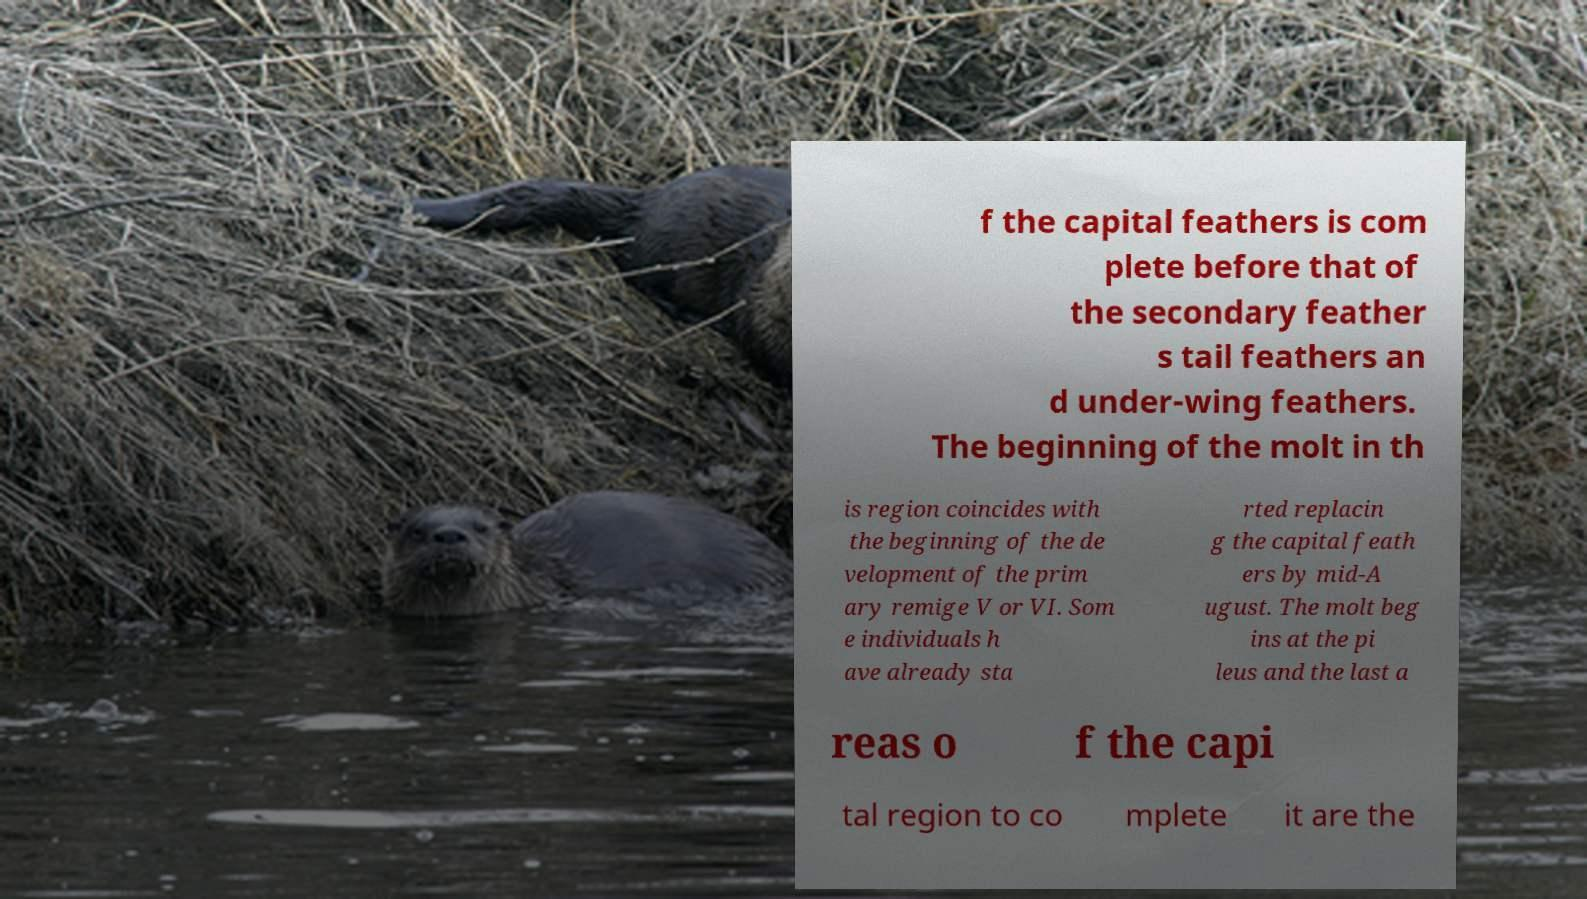Could you extract and type out the text from this image? f the capital feathers is com plete before that of the secondary feather s tail feathers an d under-wing feathers. The beginning of the molt in th is region coincides with the beginning of the de velopment of the prim ary remige V or VI. Som e individuals h ave already sta rted replacin g the capital feath ers by mid-A ugust. The molt beg ins at the pi leus and the last a reas o f the capi tal region to co mplete it are the 